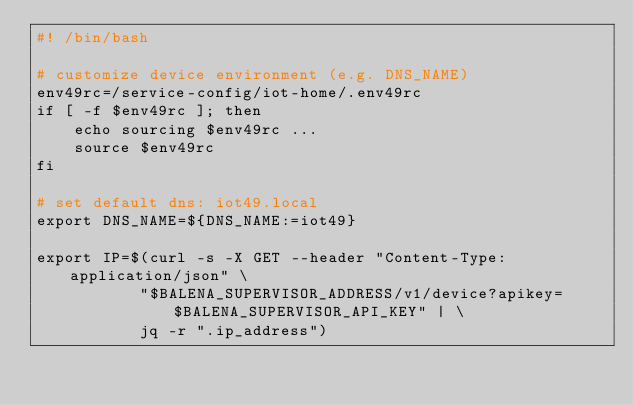<code> <loc_0><loc_0><loc_500><loc_500><_Bash_>#! /bin/bash

# customize device environment (e.g. DNS_NAME)
env49rc=/service-config/iot-home/.env49rc
if [ -f $env49rc ]; then
    echo sourcing $env49rc ...
    source $env49rc
fi

# set default dns: iot49.local
export DNS_NAME=${DNS_NAME:=iot49}

export IP=$(curl -s -X GET --header "Content-Type:application/json" \
           "$BALENA_SUPERVISOR_ADDRESS/v1/device?apikey=$BALENA_SUPERVISOR_API_KEY" | \
           jq -r ".ip_address")
</code> 